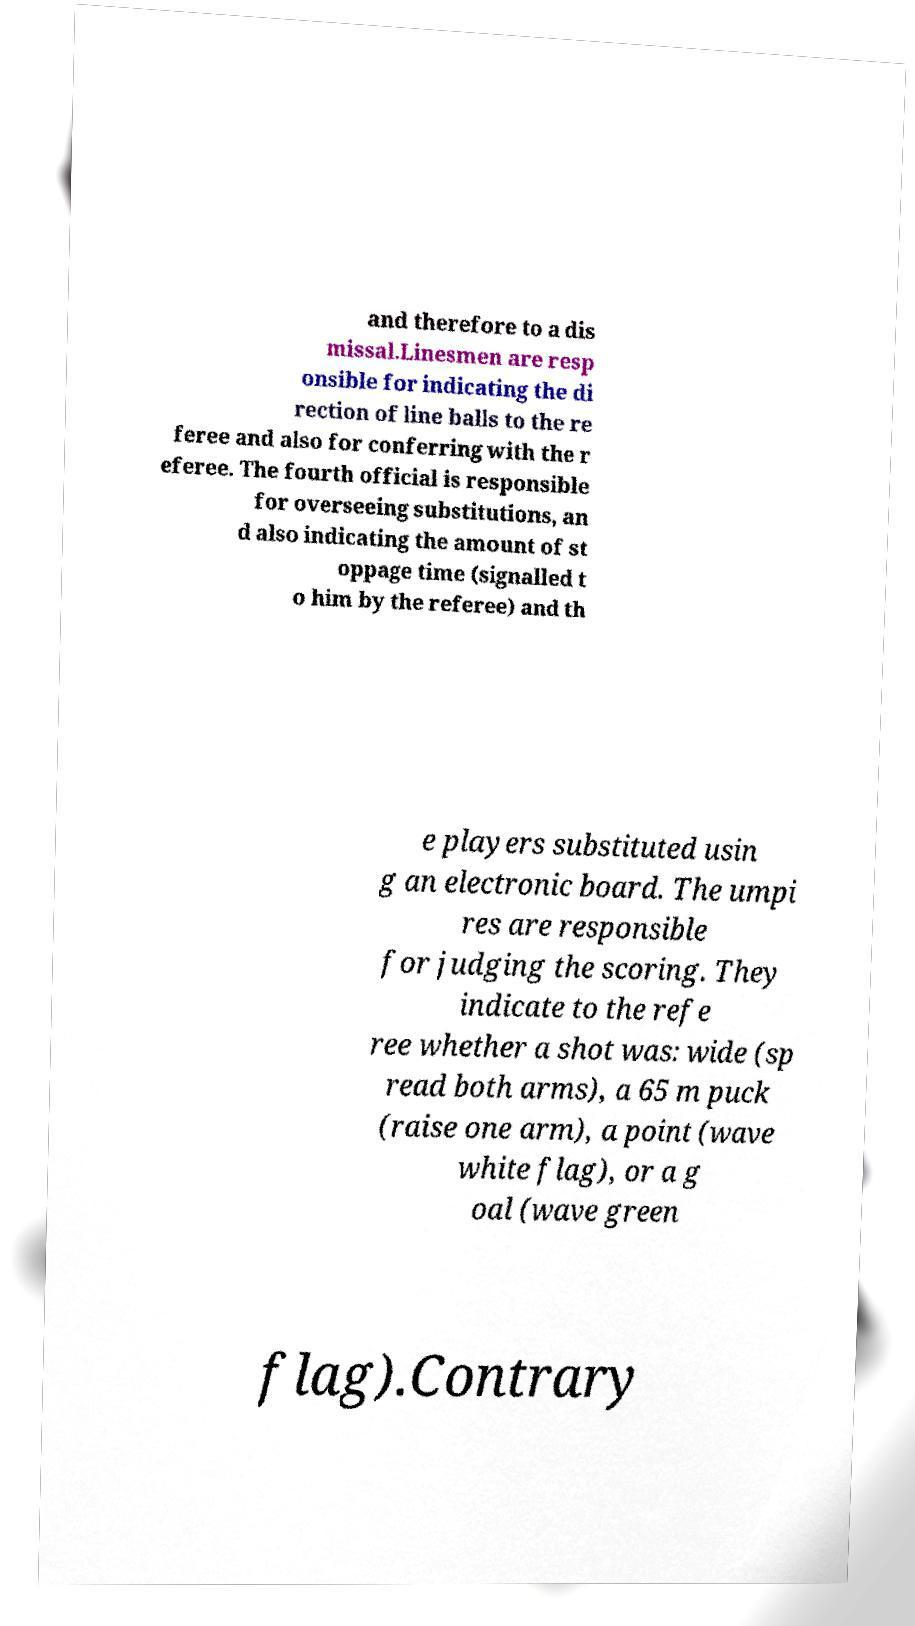Please read and relay the text visible in this image. What does it say? and therefore to a dis missal.Linesmen are resp onsible for indicating the di rection of line balls to the re feree and also for conferring with the r eferee. The fourth official is responsible for overseeing substitutions, an d also indicating the amount of st oppage time (signalled t o him by the referee) and th e players substituted usin g an electronic board. The umpi res are responsible for judging the scoring. They indicate to the refe ree whether a shot was: wide (sp read both arms), a 65 m puck (raise one arm), a point (wave white flag), or a g oal (wave green flag).Contrary 